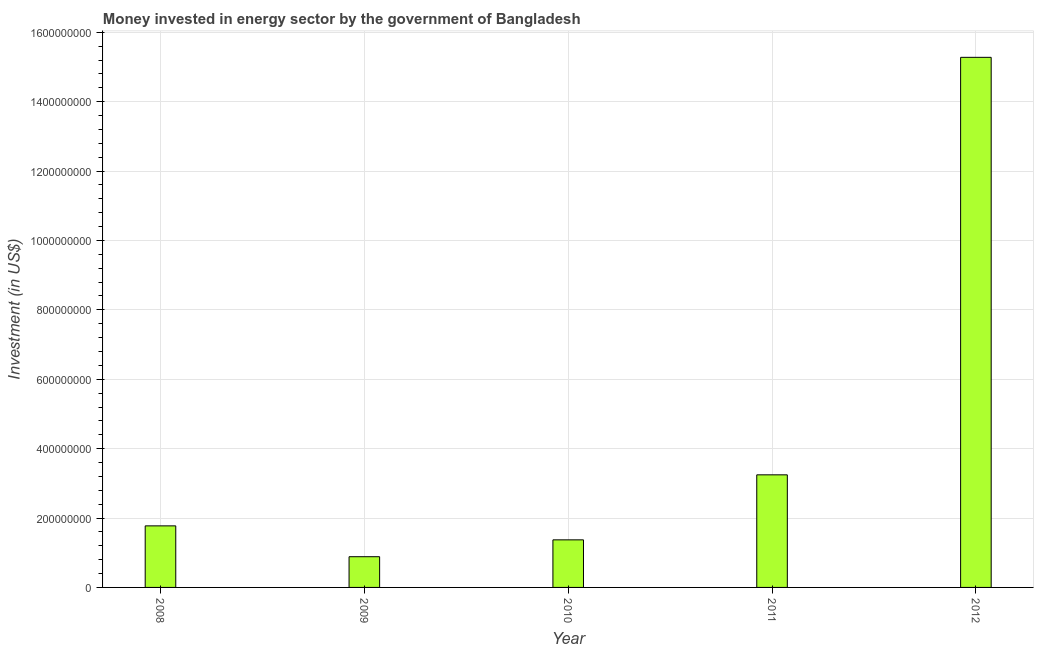Does the graph contain any zero values?
Your answer should be very brief. No. What is the title of the graph?
Keep it short and to the point. Money invested in energy sector by the government of Bangladesh. What is the label or title of the Y-axis?
Ensure brevity in your answer.  Investment (in US$). What is the investment in energy in 2009?
Your response must be concise. 8.85e+07. Across all years, what is the maximum investment in energy?
Provide a short and direct response. 1.53e+09. Across all years, what is the minimum investment in energy?
Offer a terse response. 8.85e+07. In which year was the investment in energy minimum?
Your answer should be very brief. 2009. What is the sum of the investment in energy?
Provide a succinct answer. 2.26e+09. What is the difference between the investment in energy in 2008 and 2009?
Ensure brevity in your answer.  8.89e+07. What is the average investment in energy per year?
Your answer should be very brief. 4.51e+08. What is the median investment in energy?
Your answer should be compact. 1.77e+08. Do a majority of the years between 2008 and 2011 (inclusive) have investment in energy greater than 1360000000 US$?
Your answer should be compact. No. What is the ratio of the investment in energy in 2009 to that in 2011?
Ensure brevity in your answer.  0.27. Is the investment in energy in 2009 less than that in 2010?
Offer a very short reply. Yes. What is the difference between the highest and the second highest investment in energy?
Ensure brevity in your answer.  1.20e+09. Is the sum of the investment in energy in 2010 and 2011 greater than the maximum investment in energy across all years?
Make the answer very short. No. What is the difference between the highest and the lowest investment in energy?
Give a very brief answer. 1.44e+09. Are all the bars in the graph horizontal?
Offer a very short reply. No. How many years are there in the graph?
Your answer should be compact. 5. What is the Investment (in US$) of 2008?
Make the answer very short. 1.77e+08. What is the Investment (in US$) of 2009?
Keep it short and to the point. 8.85e+07. What is the Investment (in US$) in 2010?
Provide a succinct answer. 1.37e+08. What is the Investment (in US$) in 2011?
Offer a very short reply. 3.25e+08. What is the Investment (in US$) in 2012?
Keep it short and to the point. 1.53e+09. What is the difference between the Investment (in US$) in 2008 and 2009?
Ensure brevity in your answer.  8.89e+07. What is the difference between the Investment (in US$) in 2008 and 2010?
Provide a succinct answer. 4.03e+07. What is the difference between the Investment (in US$) in 2008 and 2011?
Offer a very short reply. -1.47e+08. What is the difference between the Investment (in US$) in 2008 and 2012?
Offer a terse response. -1.35e+09. What is the difference between the Investment (in US$) in 2009 and 2010?
Provide a succinct answer. -4.86e+07. What is the difference between the Investment (in US$) in 2009 and 2011?
Keep it short and to the point. -2.36e+08. What is the difference between the Investment (in US$) in 2009 and 2012?
Offer a terse response. -1.44e+09. What is the difference between the Investment (in US$) in 2010 and 2011?
Your answer should be very brief. -1.87e+08. What is the difference between the Investment (in US$) in 2010 and 2012?
Offer a very short reply. -1.39e+09. What is the difference between the Investment (in US$) in 2011 and 2012?
Provide a short and direct response. -1.20e+09. What is the ratio of the Investment (in US$) in 2008 to that in 2009?
Offer a terse response. 2. What is the ratio of the Investment (in US$) in 2008 to that in 2010?
Offer a terse response. 1.29. What is the ratio of the Investment (in US$) in 2008 to that in 2011?
Offer a terse response. 0.55. What is the ratio of the Investment (in US$) in 2008 to that in 2012?
Offer a very short reply. 0.12. What is the ratio of the Investment (in US$) in 2009 to that in 2010?
Your answer should be very brief. 0.65. What is the ratio of the Investment (in US$) in 2009 to that in 2011?
Your answer should be compact. 0.27. What is the ratio of the Investment (in US$) in 2009 to that in 2012?
Offer a terse response. 0.06. What is the ratio of the Investment (in US$) in 2010 to that in 2011?
Your response must be concise. 0.42. What is the ratio of the Investment (in US$) in 2010 to that in 2012?
Your response must be concise. 0.09. What is the ratio of the Investment (in US$) in 2011 to that in 2012?
Your answer should be compact. 0.21. 